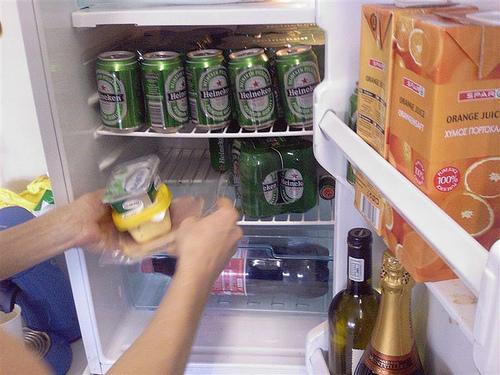What type of drinks are in the green cans?
Give a very brief answer. Beer. What is in the orange container?
Quick response, please. Orange juice. What is the man holding?
Answer briefly. Food. 